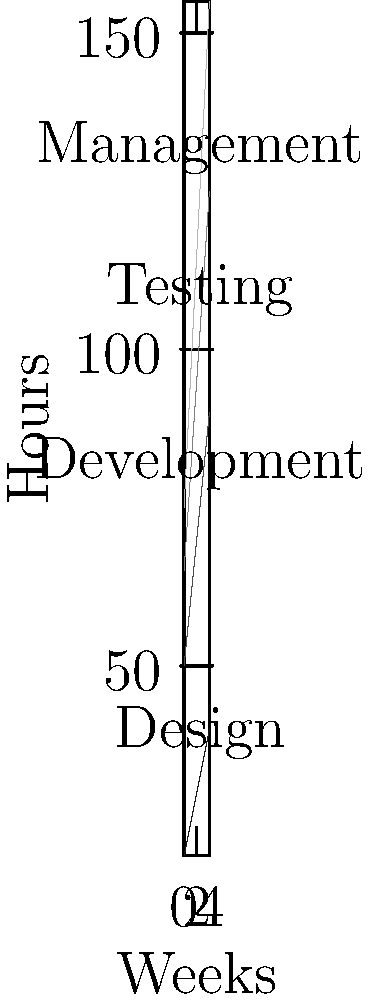The stacked area chart shows the allocation of hours across different team roles over a 5-week period. What is the total number of hours allocated to the Development team over the entire period, and what percentage does this represent of the total project hours? To solve this problem, we need to follow these steps:

1. Calculate the total hours for Development:
   Week 1: 30 hours
   Week 2: 35 hours
   Week 3: 40 hours
   Week 4: 45 hours
   Week 5: 50 hours
   Total = 30 + 35 + 40 + 45 + 50 = 200 hours

2. Calculate the total project hours:
   For each week, sum up the hours for all roles:
   Week 1: 20 + 30 + 15 + 10 = 75 hours
   Week 2: 25 + 35 + 20 + 15 = 95 hours
   Week 3: 30 + 40 + 25 + 20 = 115 hours
   Week 4: 35 + 45 + 30 + 25 = 135 hours
   Week 5: 40 + 50 + 35 + 30 = 155 hours
   Total project hours = 75 + 95 + 115 + 135 + 155 = 575 hours

3. Calculate the percentage:
   Percentage = (Development hours / Total project hours) * 100
   = (200 / 575) * 100
   ≈ 34.78%
Answer: 200 hours, 34.78% of total project hours 